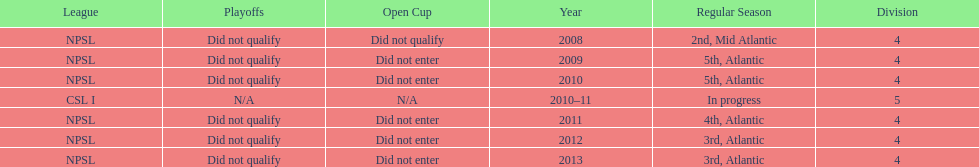What is the lowest place they came in 5th. 